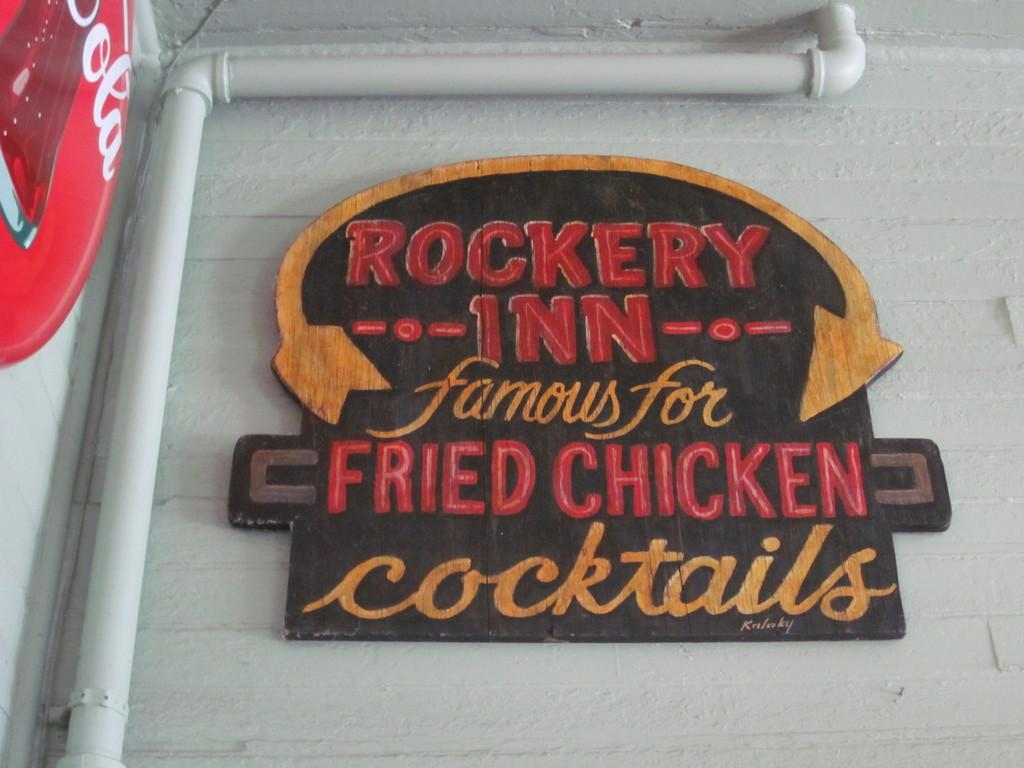What is attached to the wall in the image? There is a board on the wall in the image. What can be seen on the left side of the image? There is a pipeline on the left side of the image. Where is the cow located in the image? There is no cow present in the image. What type of doll can be seen playing on the swing in the image? There is no doll or swing present in the image. 